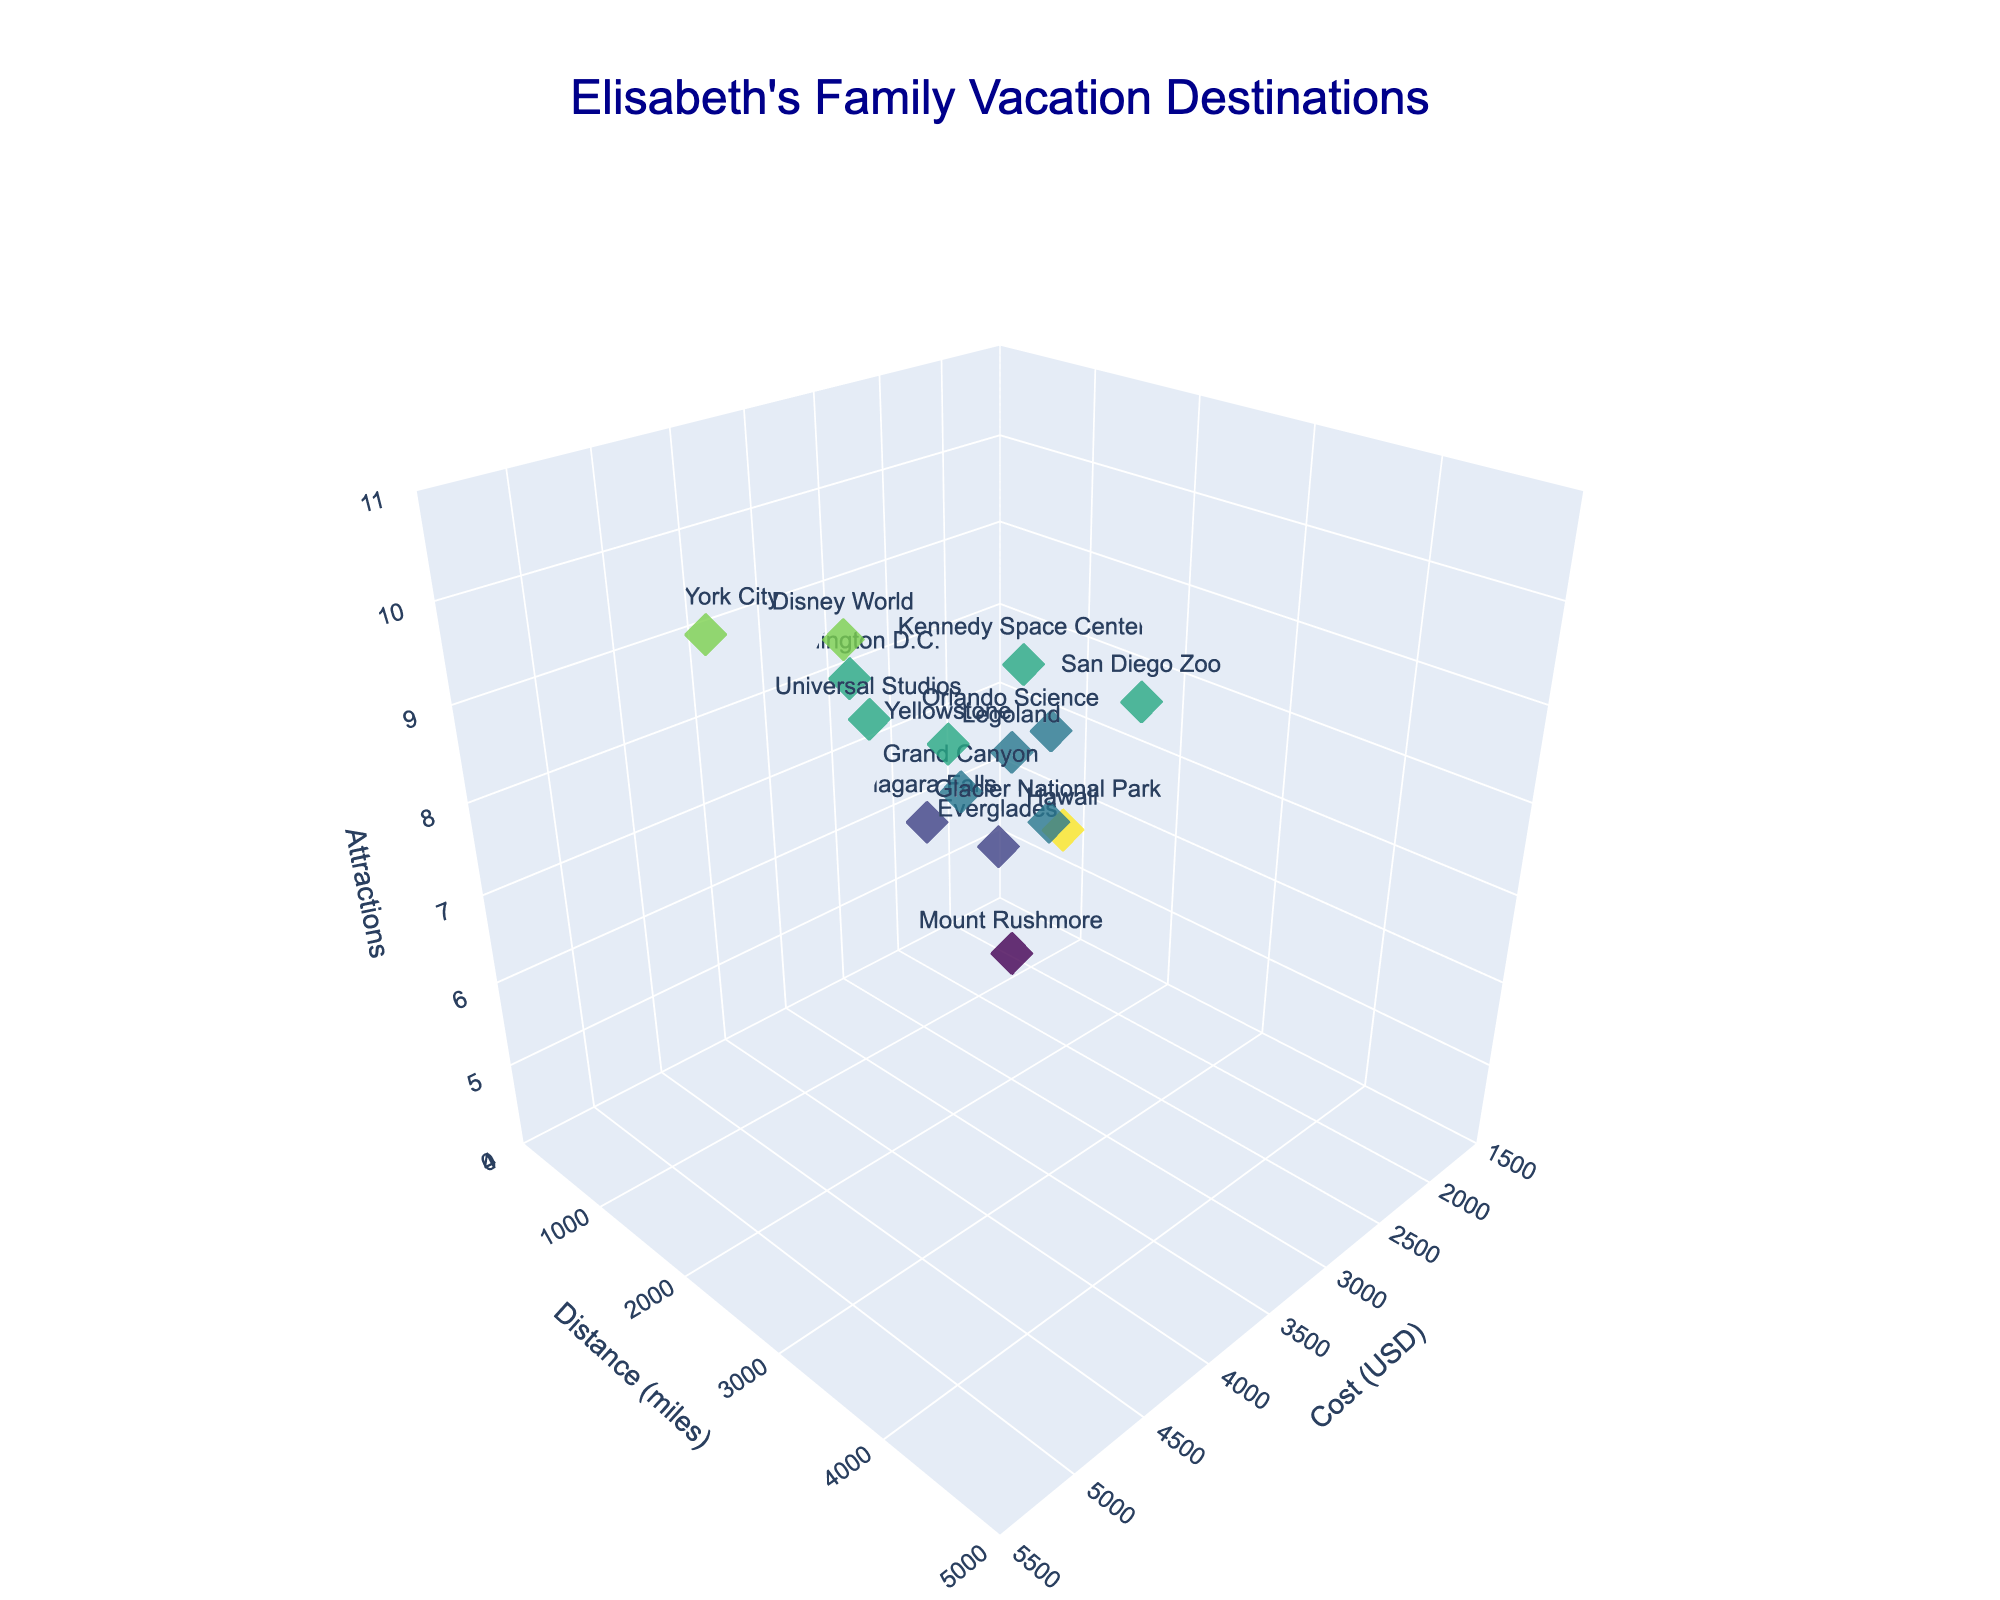How many vacation destinations have more than 8 attractions? There are two destinations that have more than 8 attractions: Disney World and Hawaii, which have 9 and 10 attractions respectively.
Answer: 2 Which destination is the least expensive but has at least 7 attractions? The least expensive destination with at least 7 attractions is the Orlando Science Center, with a cost of 1800 USD and 7 attractions.
Answer: Orlando Science Center What's the difference in distance between New York City and San Diego Zoo? The distance for New York City is 200 miles, and for San Diego Zoo, it is 2100 miles. The difference is 2100 - 200 = 1900 miles.
Answer: 1900 miles Which destination is the farthest from home, and how many attractions does it have? The farthest destination is Hawaii at 4800 miles, which has 10 attractions.
Answer: 4800 miles, 10 attractions Which destination costs the most, and how many miles away is it? The most expensive destination is Hawaii, costing 5000 USD and it is 4800 miles away.
Answer: Hawaii, 4800 miles How many destinations have a cost between 2500 USD and 3000 USD? The destinations in the cost range of 2500 USD and 3000 USD are Niagara Falls, Grand Canyon, Washington D.C., and Glacier National Park. So, there are 4 destinations within this range.
Answer: 4 What's the average cost of destinations that are within 1000 miles? The destinations within 1000 miles are Disney World (3500 USD), Niagara Falls (2500 USD), New York City (4000 USD), Universal Studios (3300 USD), and Orlando Science Center (1800 USD). The total cost for these is 3500+2500+4000+3300+1800 = 15100 USD. The number of destinations is 5, so the average cost is 15100/5 = 3020 USD.
Answer: 3020 USD Which destination has the second highest number of attractions, and what is its cost? The second highest number of attractions is 9, which belongs to both Disney World and New York City. The costs of these destinations are 3500 USD and 4000 USD, respectively.
Answer: Disney World: 3500 USD, New York City: 4000 USD Compare the distances and attractions of Grand Canyon and Mount Rushmore. Grand Canyon is 1200 miles away with 7 attractions, while Mount Rushmore is 1500 miles away with 5 attractions. The Grand Canyon is closer and has more attractions compared to Mount Rushmore.
Answer: Grand Canyon: 1200 miles, 7 attractions; Mount Rushmore: 1500 miles, 5 attractions 